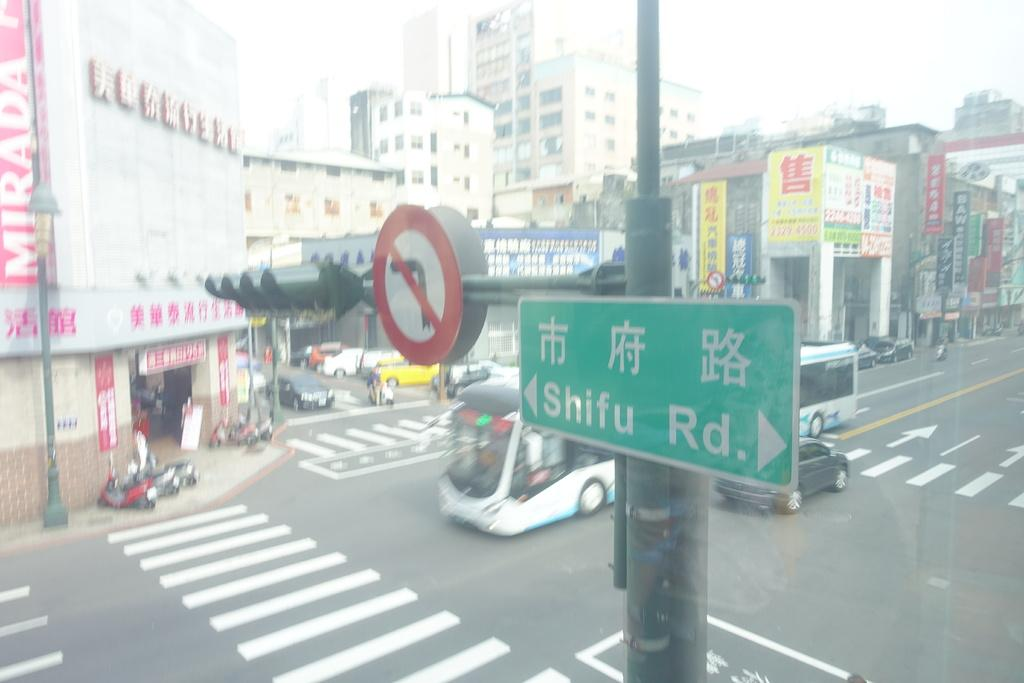<image>
Render a clear and concise summary of the photo. a cross section of the street at the intersection of Shifu Rd 